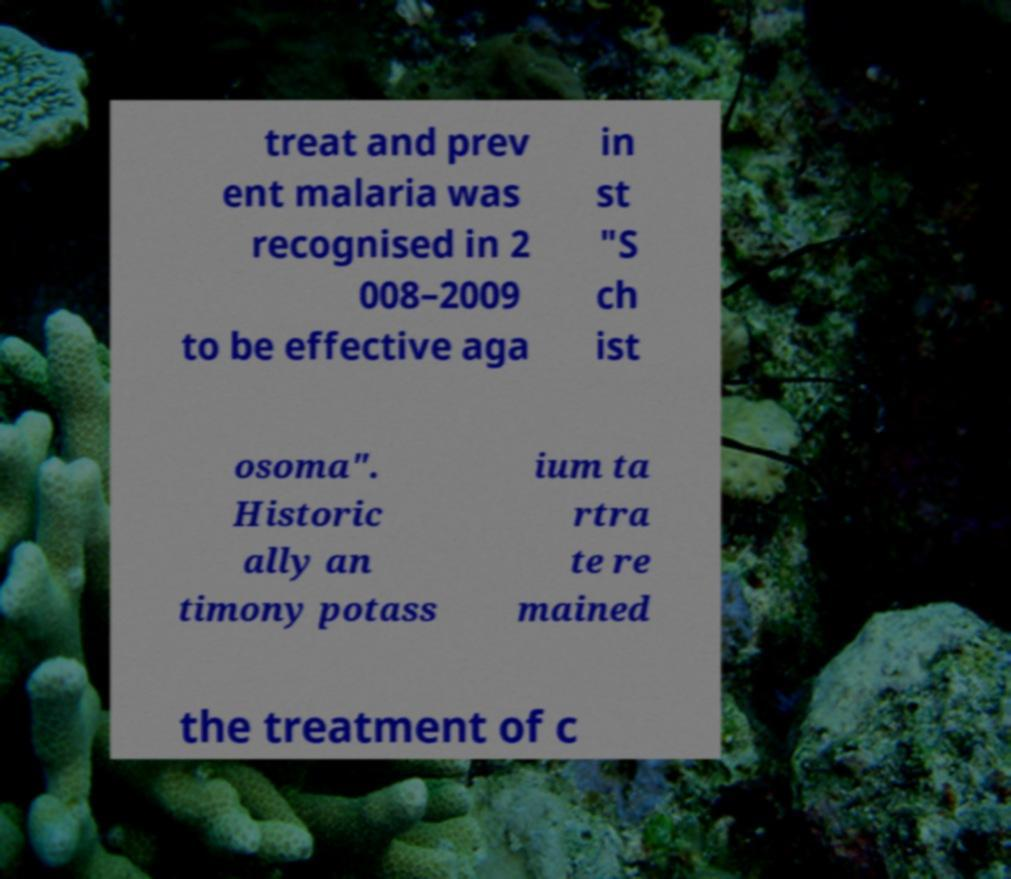What messages or text are displayed in this image? I need them in a readable, typed format. treat and prev ent malaria was recognised in 2 008–2009 to be effective aga in st "S ch ist osoma". Historic ally an timony potass ium ta rtra te re mained the treatment of c 